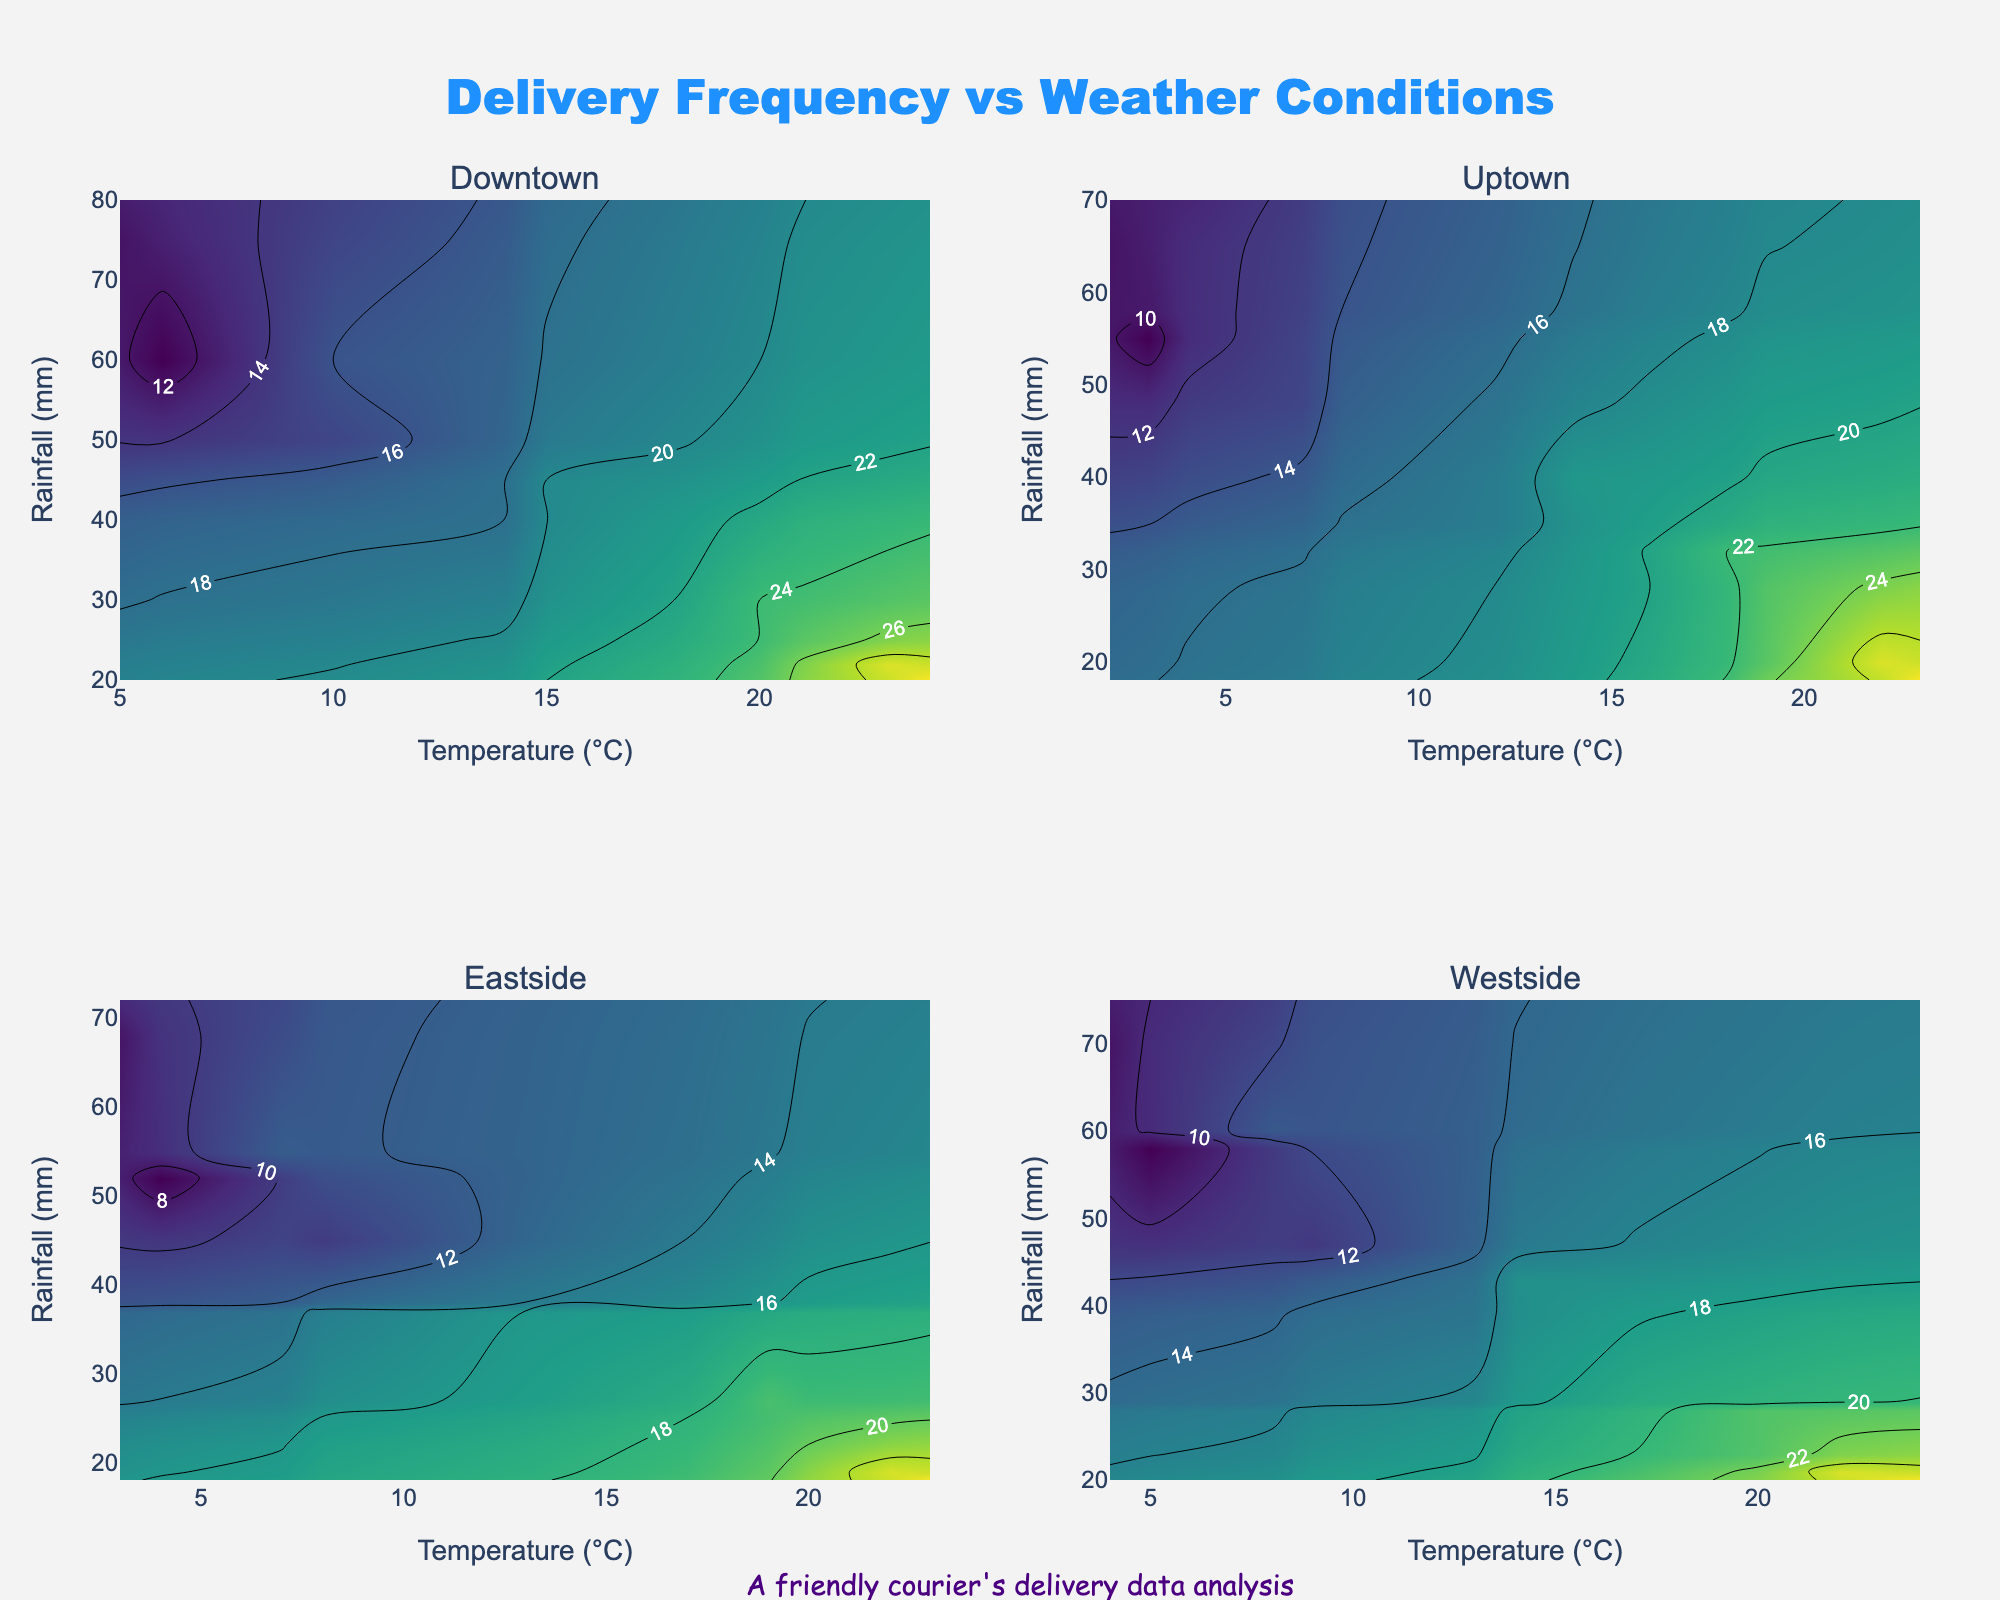What is the title of the figure? The title is displayed at the top center of the figure, reading "Delivery Frequency vs Weather Conditions".
Answer: Delivery Frequency vs Weather Conditions What variables are plotted on the x and y axes? The x-axis represents the "Temperature (°C)" and the y-axis represents the "Rainfall (mm)". These labels are shown at the bottom and left side of each subplot respectively.
Answer: Temperature and Rainfall How many neighborhoods are represented in the subplots? There are four neighborhoods represented in the subplots. This can be inferred from the subplot titles: Downtown, Uptown, Eastside, and Westside.
Answer: Four Among the neighborhoods, where does the highest average number of deliveries occur during high-temperature and low-rainfall conditions? By examining the contour plots, we can see that Downtown shows the highest peak in delivery frequency under these conditions, as indicated by the darker shades and raised contour lines in the top-right region of Downtown's subplot.
Answer: Downtown Which neighborhood has the most consistent delivery rate across varying weather conditions? The neighborhood with the most consistent delivery frequency appears to be Eastside, as the contour lines are more evenly spread and less concentrated compared to others, suggesting a more uniform distribution.
Answer: Eastside In which month do deliveries in Downtown peak? By cross-referencing average deliveries with temperature and rainfall characteristics, we can determine that deliveries peak in July, as it coincides with the high-temperature, low-rainfall conditions observed in the plot.
Answer: July During what conditions do the Westside deliveries decline the most? Referring to the contour plot for Westside, deliveries decline significantly under conditions of low temperature and high rainfall as indicated by the lighter shades and more dispersed contour lines in the lower-right region.
Answer: Low temperature and high rainfall How do Uptown and Westside compare in delivery frequency at moderate temperatures and rainfall? Observing the contour plots of both neighborhoods, it can be seen that both exhibit moderate delivery rates, but Uptown has higher peaks indicated by the darker shades in mid-regions.
Answer: Uptown has higher delivery frequency Which neighborhood shows the highest variation in delivery frequency? Downtown shows the highest variation as indicated by the steep color gradient and closely packed contour lines, contrasting regions of very high and very low delivery rates.
Answer: Downtown What indicates the delivery data analysis was undergone by a friendly courier? An annotation that reads "A friendly courier's delivery data analysis" is included at the bottom center of the plot.
Answer: The annotation at the bottom 